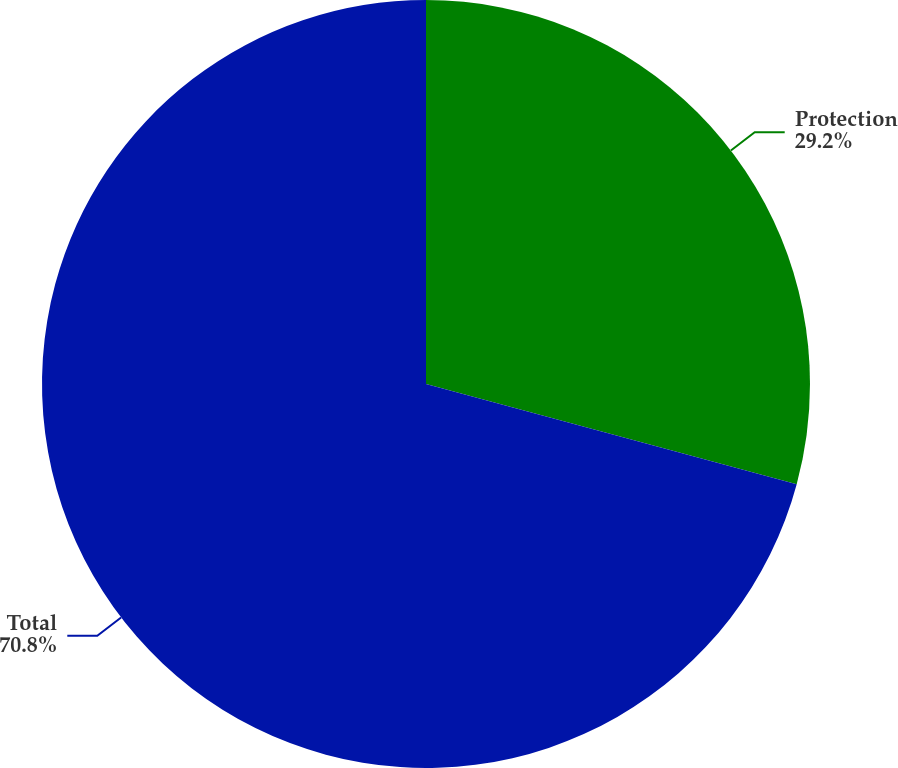Convert chart to OTSL. <chart><loc_0><loc_0><loc_500><loc_500><pie_chart><fcel>Protection<fcel>Total<nl><fcel>29.2%<fcel>70.8%<nl></chart> 